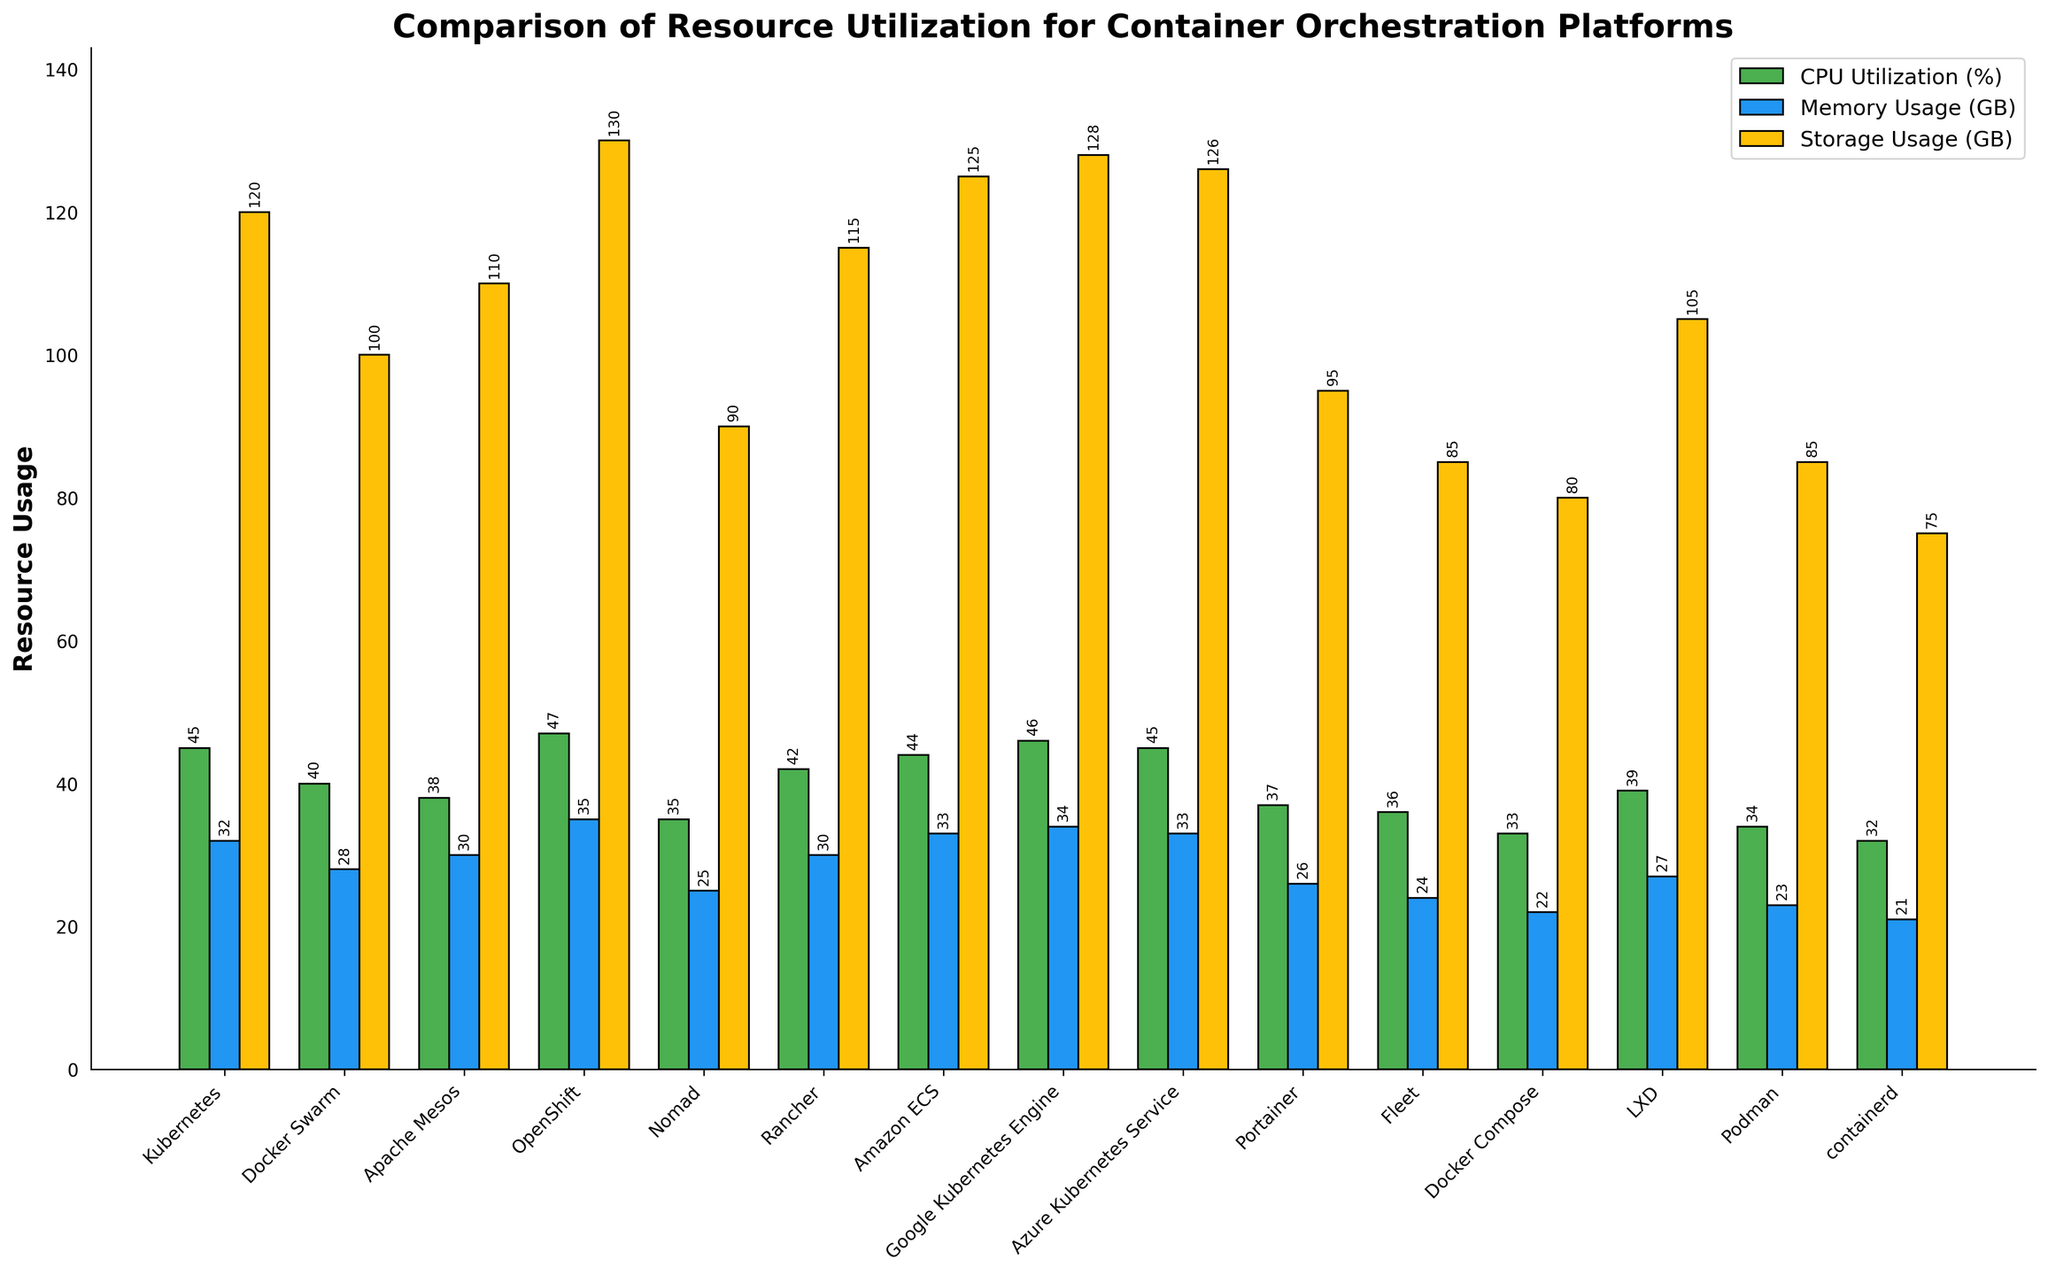which platform has the highest CPU utilization? OpenShift has the highest CPU utilization bar, colored green, and towering above the others at 47%.
Answer: OpenShift Which platform uses the lowest storage? The shortest yellow bar for storage usage is for "containerd", which is at the 75 GB mark, the minimal point among all platforms.
Answer: containerd What's the difference in memory usage between the highest and lowest platforms? The tallest blue bar is OpenShift at 35 GB (highest memory usage), and the shortest is containerd at 21 GB (lowest memory usage). Subtracting these values: 35 - 21 = 14 GB.
Answer: 14 GB Which platform utilizes more memory: Kubernetes or Docker Swarm? The blue bar for Kubernetes is at 32 GB, while Docker Swarm's blue bar is at 28 GB, so Kubernetes utilizes more memory.
Answer: Kubernetes What's the average storage usage among Kubernetes, Docker Swarm, and Apache Mesos? The storage usages for these three platforms are 120 GB (Kubernetes), 100GB (Docker Swarm), and 110 GB (Apache Mesos). The average is (120 + 100 + 110) / 3 = 110 GB.
Answer: 110 GB What’s the total CPU utilization for platforms with a usage rate above 40%? Platforms with CPU utilizations above 40% are Kubernetes (45%), OpenShift (47%), Amazon ECS (44%), Google Kubernetes Engine (46%), Azure Kubernetes Service (45%), and Rancher (42%). Summing these: 45 + 47 + 44 + 46 + 45 + 42 = 269 %.
Answer: 269 % Which platform has a higher memory usage: LXD or Podman? The blue bar for LXD is at 27 GB, while Podman's is at 23 GB, indicating LXD has a higher memory usage.
Answer: LXD How does the storage usage of Docker Compose compare to that of Fleet? The yellow bar for Docker Compose is at 80 GB, while Fleet's yellow bar is at 85 GB, so Fleet's storage usage is higher.
Answer: Fleet What's the sum of CPU utilization for Nomad, Rancher, and Fleet? The CPU utilizations are Nomad (35%), Rancher (42%), and Fleet (36%). Summing these: 35 + 42 + 36 = 113 %.
Answer: 113 % 